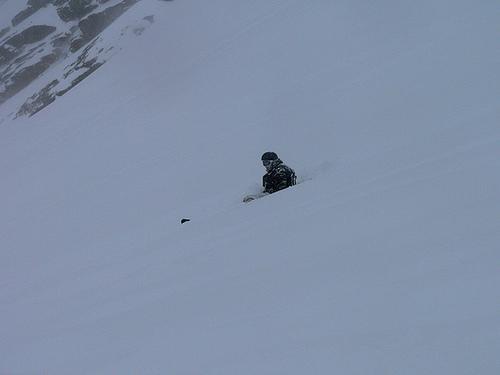How many birds are there?
Give a very brief answer. 0. 